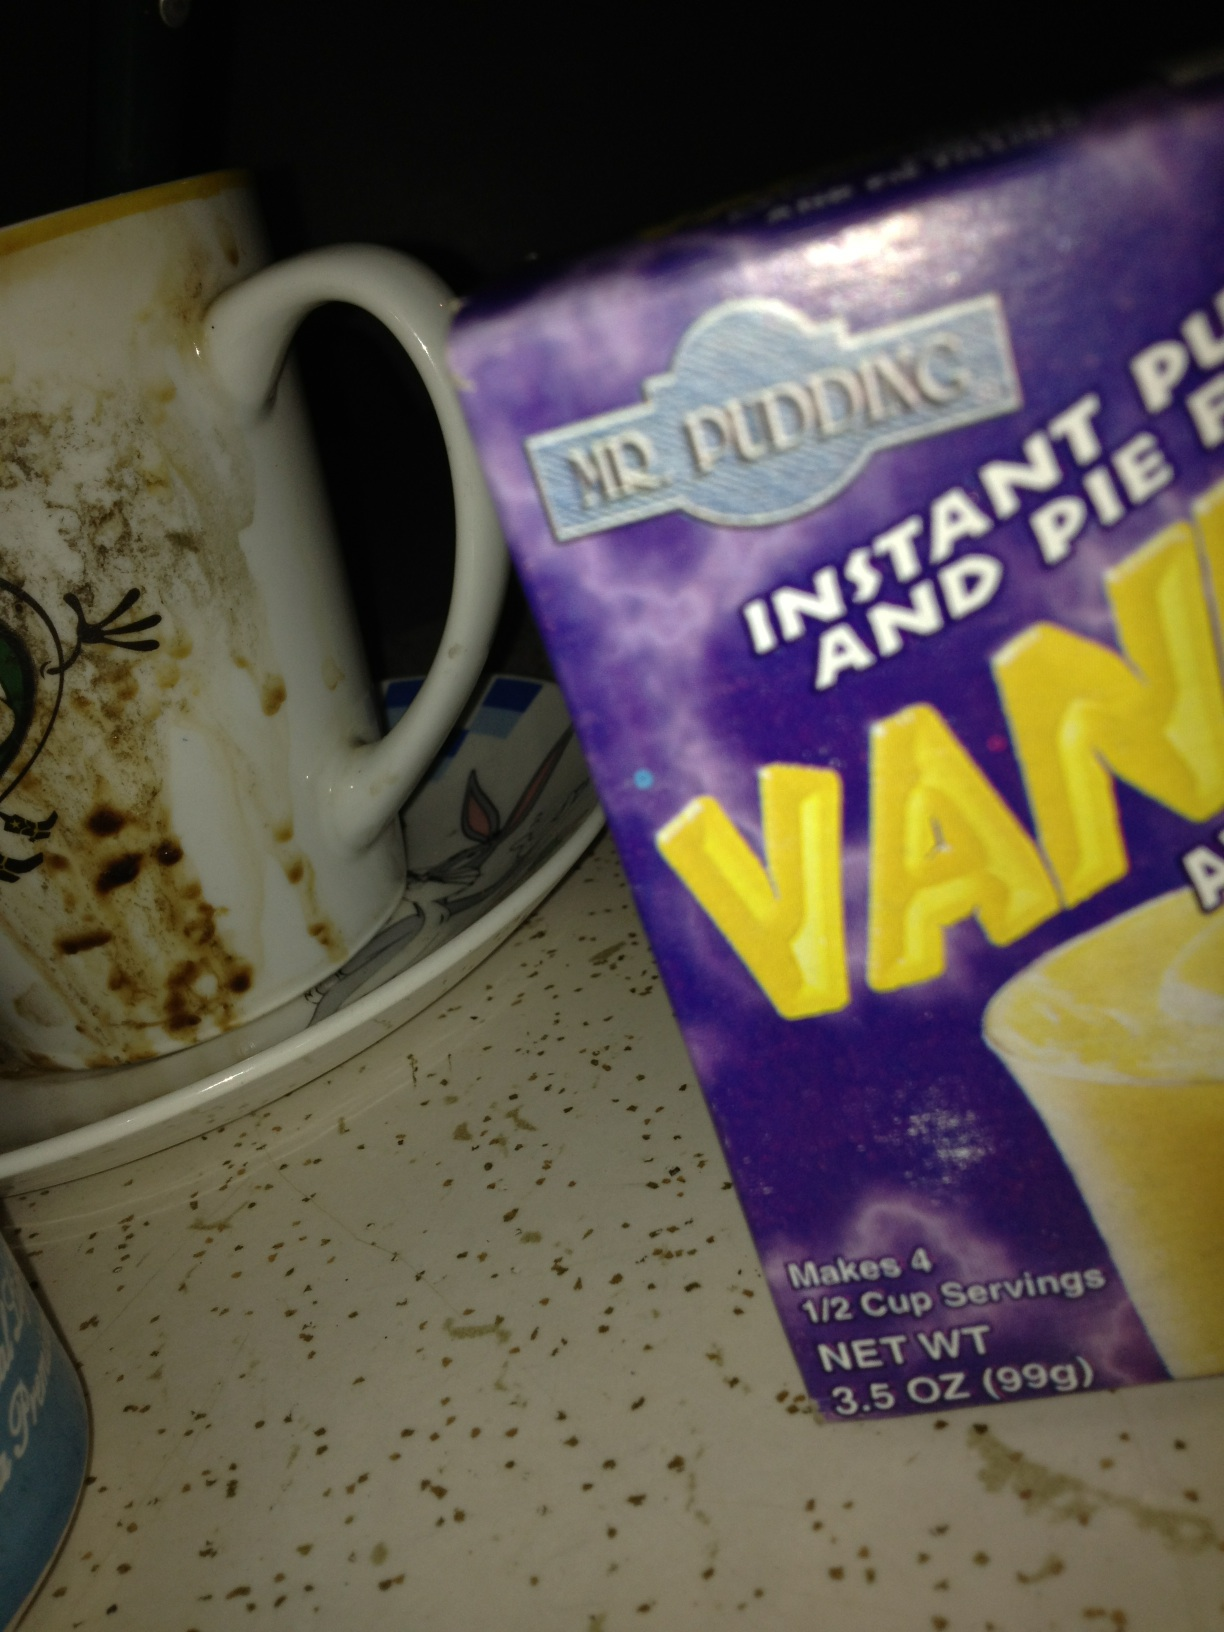Can you tell me if the pudding mix is still good to use? To determine if the pudding mix is still good, you would need to check the expiration date on the box, which isn't visible in the image. Generally, unopened pudding mix has a shelf life of several months. 